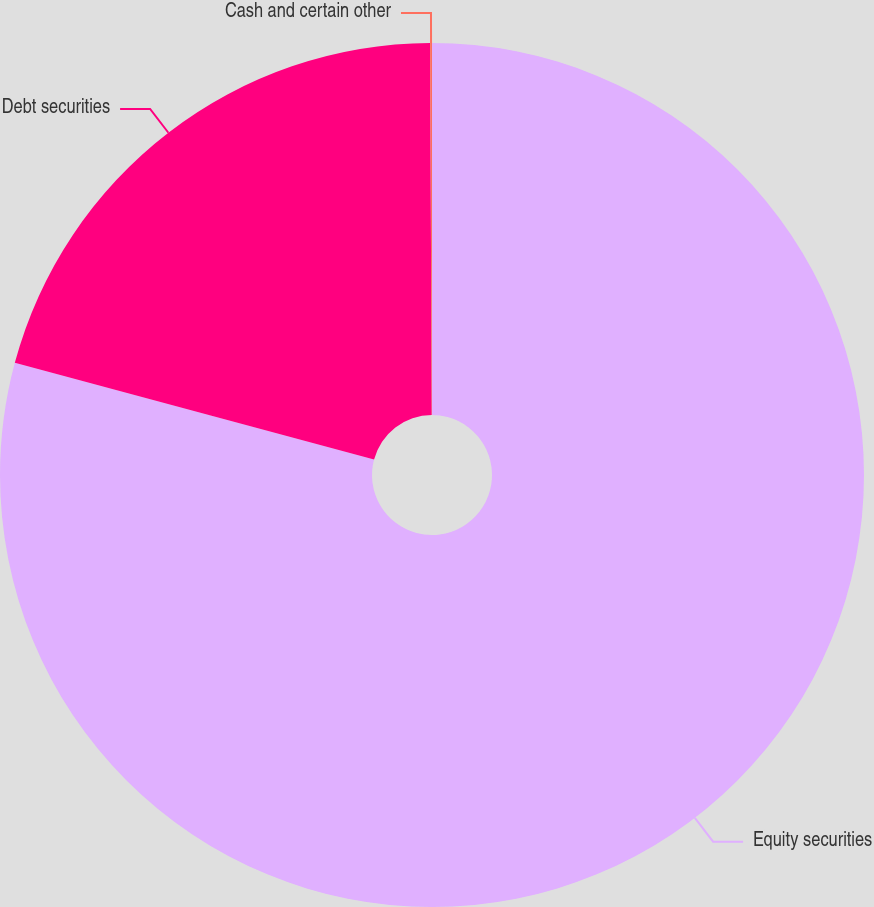Convert chart to OTSL. <chart><loc_0><loc_0><loc_500><loc_500><pie_chart><fcel>Equity securities<fcel>Debt securities<fcel>Cash and certain other<nl><fcel>79.18%<fcel>20.75%<fcel>0.07%<nl></chart> 